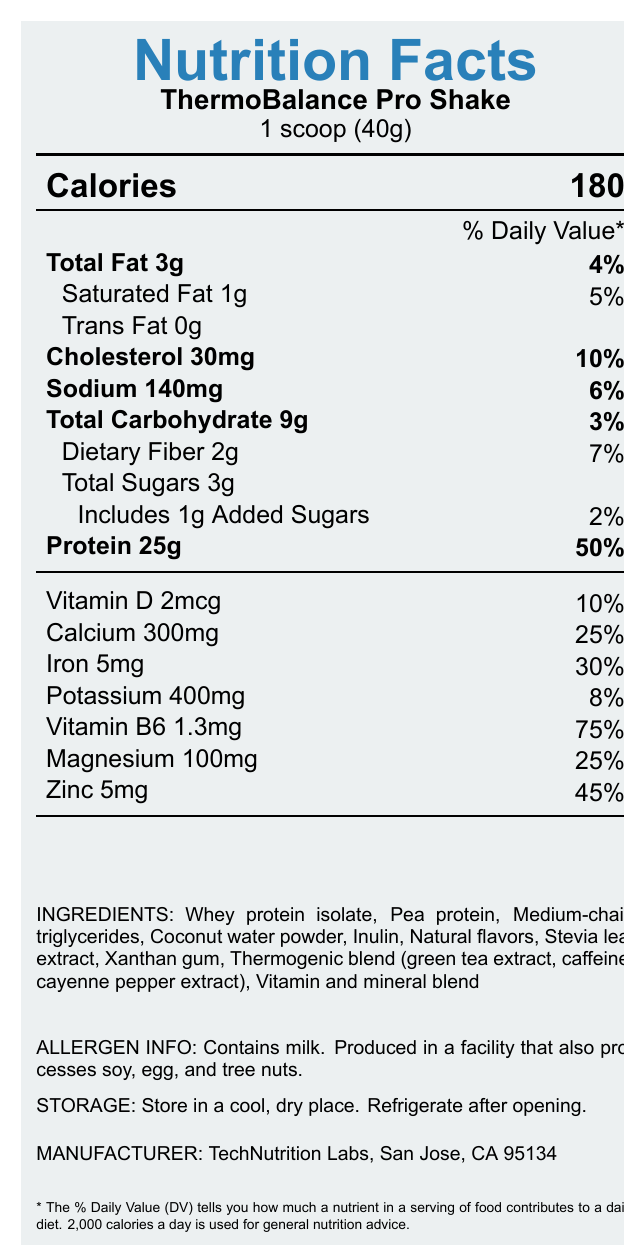what is the serving size? The serving size is specified as "1 scoop (40g)" in the document.
Answer: 1 scoop (40g) how many servings per container are there? The document states that there are 15 servings per container.
Answer: 15 how many grams of protein are in one serving? Each serving contains 25 grams of protein as shown in the document.
Answer: 25g what is the daily value percentage of vitamin B6 per serving? The document lists the daily value of vitamin B6 per serving as 75%.
Answer: 75% name two ingredients found in the ThermoBalance Pro Shake The document includes an ingredient list, from which two can be selected: Whey protein isolate and Pea protein.
Answer: Whey protein isolate, Pea protein how many calories are in one serving? A. 100 B. 150 C. 180 The document specifies that there are 180 calories in one serving.
Answer: C what is the daily value percentage of dietary fiber per serving? A. 3% B. 7% C. 10% D. 25% The daily value percentage of dietary fiber per serving is 7%, as indicated in the document.
Answer: B are there any allergens in the product? The allergen information states that the product contains milk and is produced in a facility that also processes soy, egg, and tree nuts.
Answer: Yes is the product NSF Certified for Sport? The document includes a note that the product is NSF Certified for Sport.
Answer: Yes summarize the main idea of the document The document contains a detailed breakdown of nutritional content per serving, including calories, vitamins, and minerals. It also lists the product's ingredients and provides additional information about allergens, storage, manufacturer, product features, and certifications.
Answer: The document provides detailed nutrition facts, ingredient information, and other specifications for the ThermoBalance Pro Shake. It highlights the shake's purpose for thermal regulation, high protein content, and suitability for field researchers. Additionally, it mentions allergen information, storage instructions, and certifications. what are the exact proportions of the thermogenic blend ingredients? The document only lists the thermogenic blend ingredients (green tea extract, caffeine, cayenne pepper extract) but does not provide their exact proportions.
Answer: Cannot be determined how much potassium is in one serving? One serving contains 400mg of potassium, as stated in the document.
Answer: 400mg where is the manufacturer located? The document specifies that the manufacturer, TechNutrition Labs, is located in San Jose, CA 95134.
Answer: San Jose, CA 95134 who is the intended user group of ThermoBalance Pro Shake? The product features list states that the ThermoBalance Pro Shake is suitable for field researchers and outdoor professionals.
Answer: Field researchers and outdoor professionals how much added sugar is in one serving? The document indicates that there is 1g of added sugar per serving.
Answer: 1g what is the company name that makes the ThermoBalance Pro Shake? A. TechNutrition Inc. B. TechNutrition Labs C. NutriTech Labs D. Nutrition Technologies According to the document, TechNutrition Labs is the manufacturer.
Answer: B 